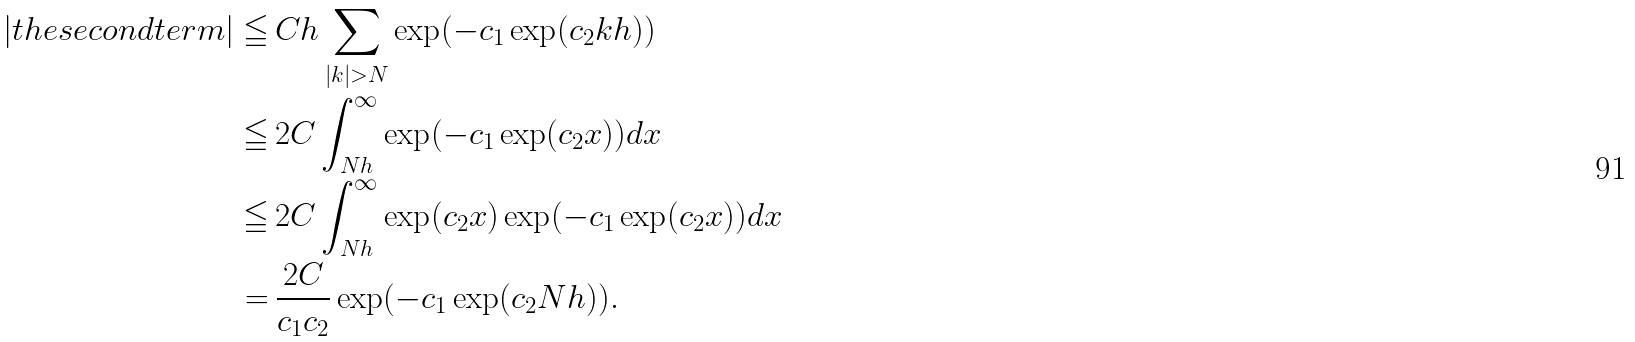<formula> <loc_0><loc_0><loc_500><loc_500>| t h e s e c o n d t e r m | \leqq \, & C h \sum _ { | k | > N } \exp ( - c _ { 1 } \exp ( c _ { 2 } k h ) ) \\ \leqq \, & 2 C \int _ { N h } ^ { \infty } \exp ( - c _ { 1 } \exp ( c _ { 2 } x ) ) d x \\ \leqq \, & 2 C \int _ { N h } ^ { \infty } \exp ( c _ { 2 } x ) \exp ( - c _ { 1 } \exp ( c _ { 2 } x ) ) d x \\ = \, & \frac { 2 C } { c _ { 1 } c _ { 2 } } \exp ( - c _ { 1 } \exp ( c _ { 2 } N h ) ) .</formula> 